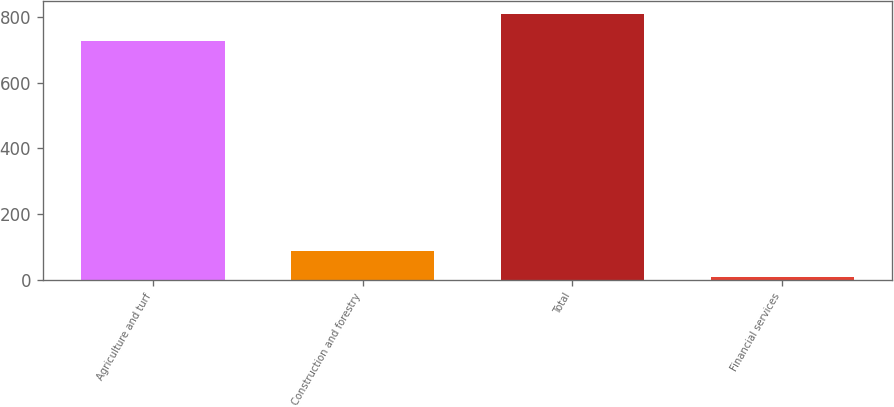Convert chart to OTSL. <chart><loc_0><loc_0><loc_500><loc_500><bar_chart><fcel>Agriculture and turf<fcel>Construction and forestry<fcel>Total<fcel>Financial services<nl><fcel>729<fcel>86.5<fcel>808.5<fcel>7<nl></chart> 